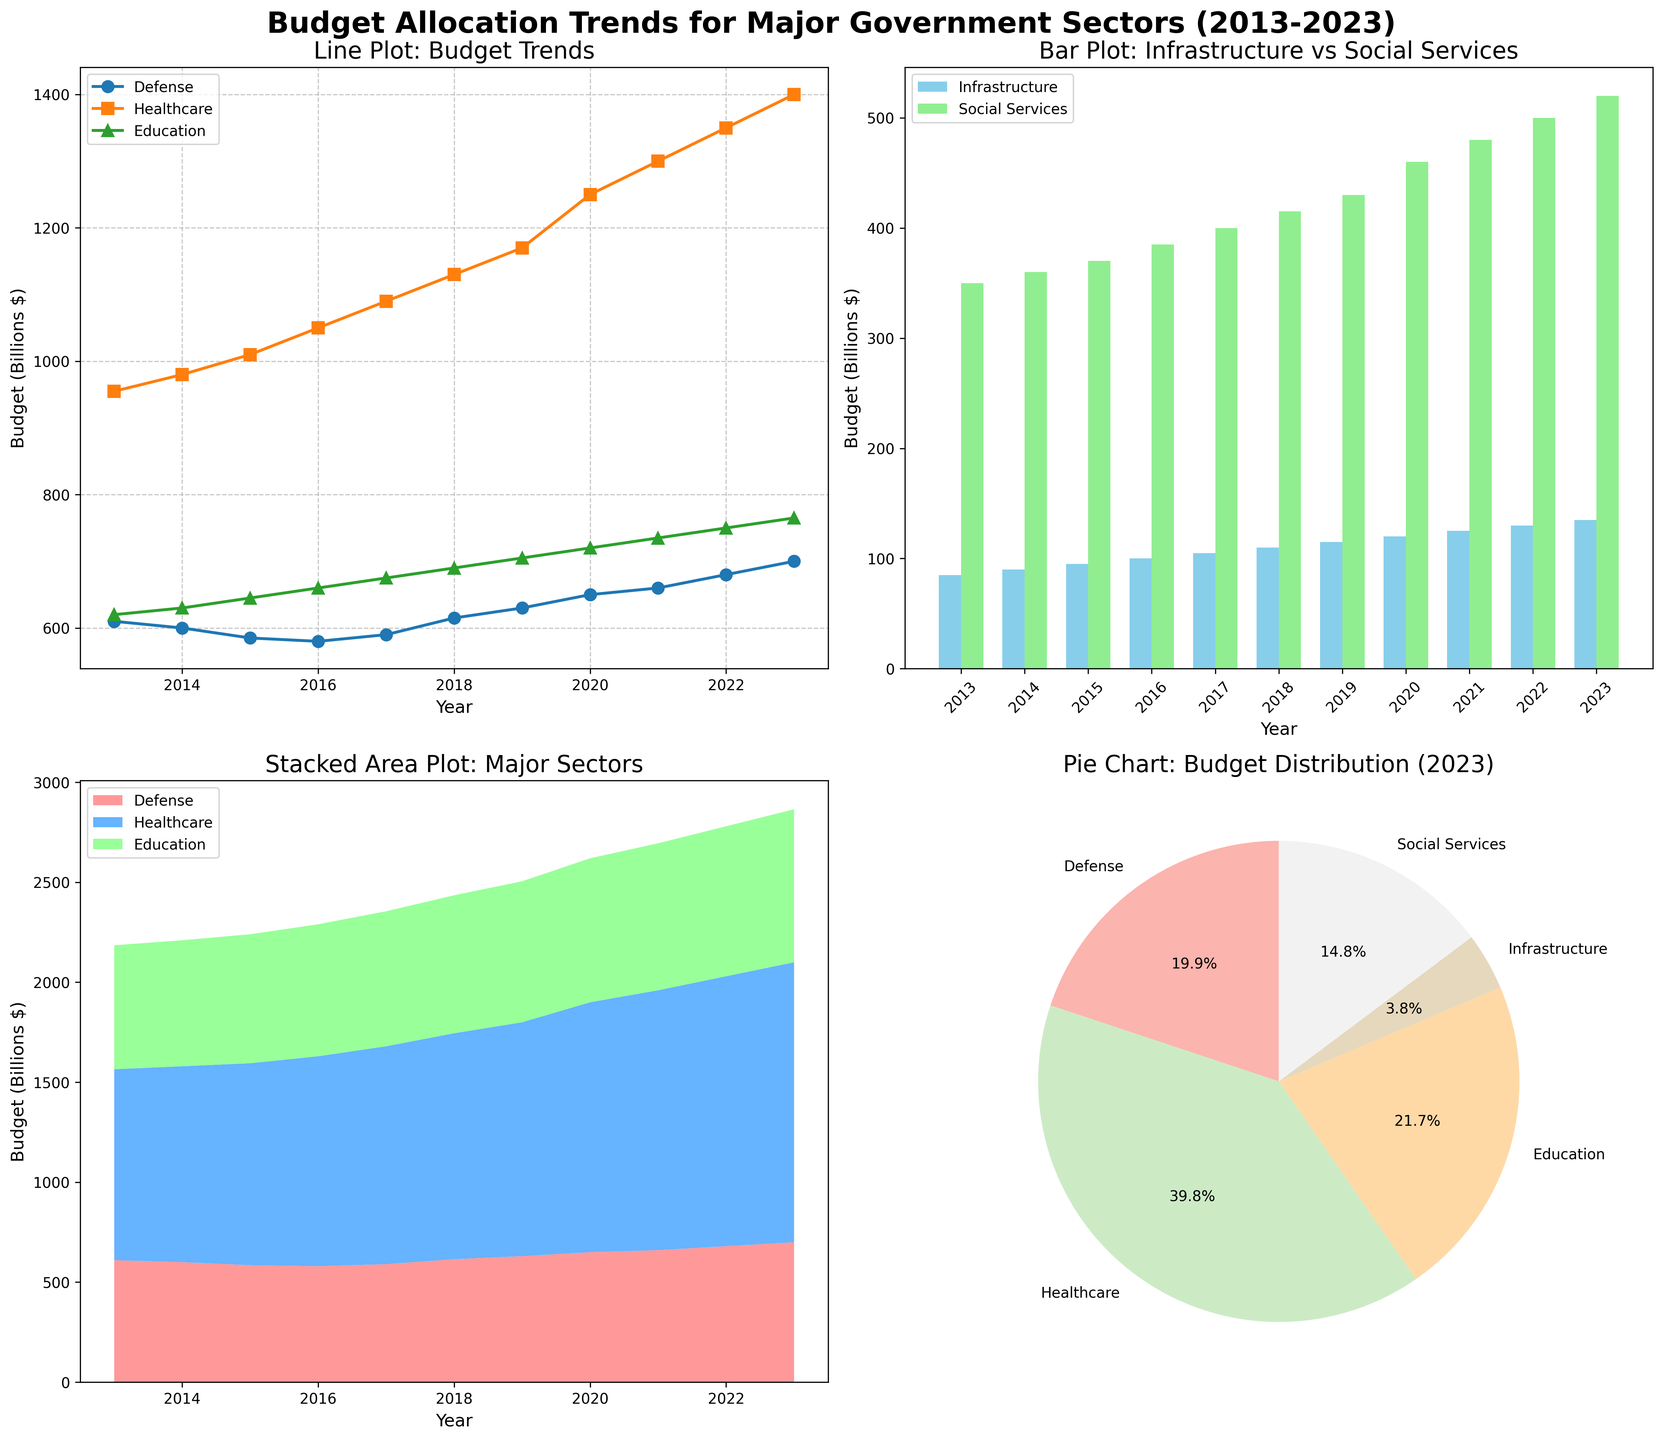Which sector saw the highest budget allocation in 2023, and what is the percentage share of that sector? Looking at the pie chart for 2023, Healthcare has the largest segment, with a percentage of 37.5%. Since it visually occupies the largest portion of the pie. The marked percentage is directly in that portion of the pie chart.
Answer: Healthcare, 37.5% What is the overall trend in healthcare budget allocation from 2013 to 2023? Referring to the line plot, the healthcare budget consistently increased from $955 billion in 2013 to $1400 billion in 2023. The trend line moves upwards steadily across the years.
Answer: Increasing trend Comparing the budgets for infrastructure and social services in 2020, which one is higher and by how much? Looking at the bar plot for 2020, the bar representing Social Services is taller than Infrastructure. Social Services in 2020 had $460 billion and Infrastructure had $120 billion, so Social Services had $340 billion more.
Answer: Social Services, $340 billion In the stacked area plot, what is the total budget allocated for Defense, Healthcare, and Education in 2019? To find the total budget for 2019, sum the values from the stacked area plot for Defense, Healthcare, and Education. The values for 2019 are Defense ($630 billion), Healthcare ($1170 billion), and Education ($705 billion). Adding these up: $630 + $1170 + $705 = $2505 billion.
Answer: $2505 billion From the line plot, how does the budget allocation for Education in 2015 compare to that in 2018? The line plot shows that in 2015, the budget for Education was $645 billion, while in 2018, it was $690 billion. By subtracting, the increase is $690 - $645 = $45 billion.
Answer: $45 billion more in 2018 What visual element indicates the dominating budget allocation in the pie chart of 2023? The largest segment of the pie chart represents Healthcare, which dominates other sectors. The size and labeled percentage indicate dominance.
Answer: Largest segment size How did the budget for Infrastructure change between 2015 and 2023 according to the bar plot? In the bar plot, the budget for Infrastructure in 2015 is $95 billion and in 2023 is $135 billion. The difference is calculated as $135 billion - $95 billion = $40 billion.
Answer: Increased by $40 billion Comparing the budget trends for Defense and Education, which sector shows more variation over the years? By examining the line plot, Defense shows a relatively stable trend compared to Education, which shows consistent growth reflecting more variation over the years.
Answer: Education In the stacked area plot, which sector has the smallest share in total budget allocation consistently over the years? Based on the stacked area plot, Education consistently has the smallest share in comparison to Defense and Healthcare. This is visible from the relatively smaller stacked area portion it occupies.
Answer: Education 